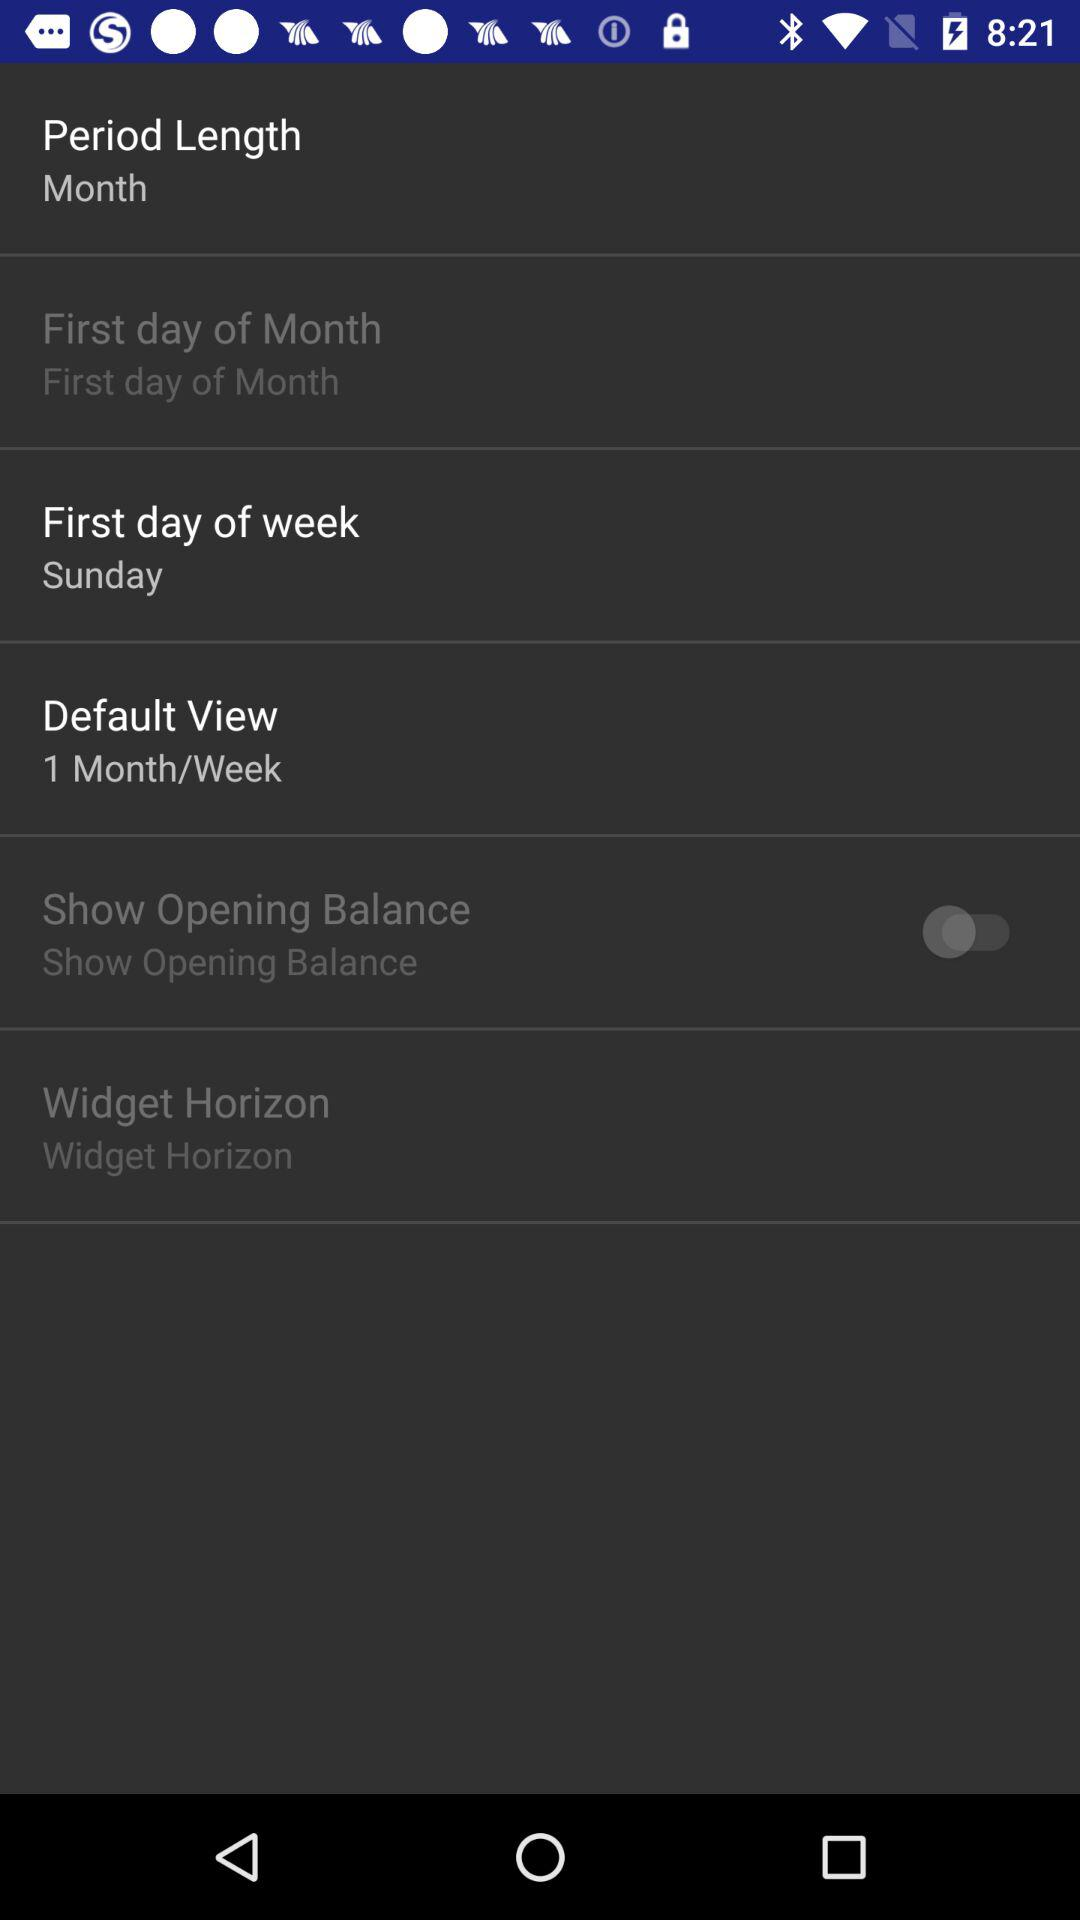What is the status of "Show Opening Balance"? The status of "Show Opening Balance" is "off". 